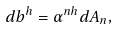<formula> <loc_0><loc_0><loc_500><loc_500>d b ^ { h } = \alpha ^ { n h } d A _ { n } ,</formula> 